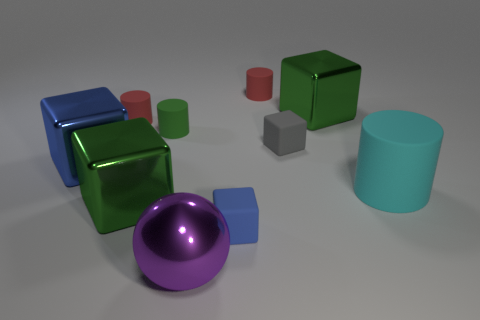Are there fewer green rubber objects behind the blue rubber block than large blue blocks?
Offer a very short reply. No. How many green rubber balls are there?
Make the answer very short. 0. There is a big blue shiny thing; is it the same shape as the metallic object to the right of the shiny sphere?
Provide a succinct answer. Yes. Are there fewer rubber objects that are on the left side of the purple metal ball than cyan things right of the large rubber cylinder?
Provide a succinct answer. No. Are there any other things that are the same shape as the purple thing?
Offer a very short reply. No. Is the shape of the blue rubber object the same as the tiny gray matte thing?
Offer a very short reply. Yes. Are there any other things that are made of the same material as the small green cylinder?
Offer a very short reply. Yes. How big is the blue shiny thing?
Your answer should be very brief. Large. There is a big thing that is on the left side of the big cylinder and right of the gray cube; what is its color?
Provide a succinct answer. Green. Is the number of small red balls greater than the number of blue rubber things?
Ensure brevity in your answer.  No. 